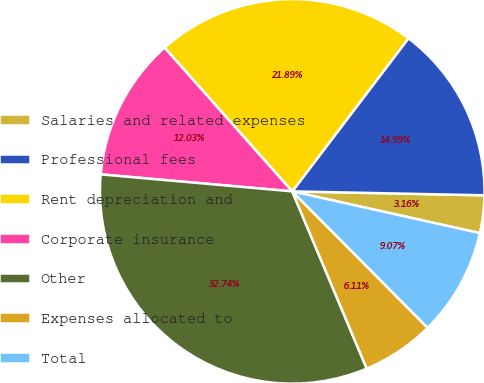Convert chart to OTSL. <chart><loc_0><loc_0><loc_500><loc_500><pie_chart><fcel>Salaries and related expenses<fcel>Professional fees<fcel>Rent depreciation and<fcel>Corporate insurance<fcel>Other<fcel>Expenses allocated to<fcel>Total<nl><fcel>3.16%<fcel>14.99%<fcel>21.89%<fcel>12.03%<fcel>32.74%<fcel>6.11%<fcel>9.07%<nl></chart> 